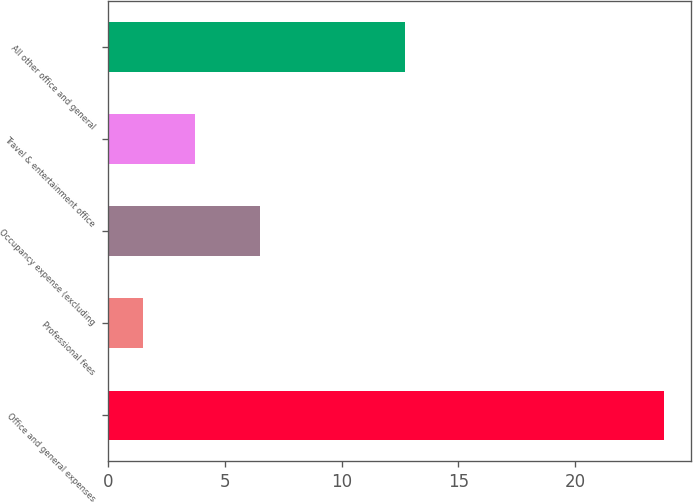Convert chart. <chart><loc_0><loc_0><loc_500><loc_500><bar_chart><fcel>Office and general expenses<fcel>Professional fees<fcel>Occupancy expense (excluding<fcel>Travel & entertainment office<fcel>All other office and general<nl><fcel>23.8<fcel>1.5<fcel>6.5<fcel>3.73<fcel>12.7<nl></chart> 